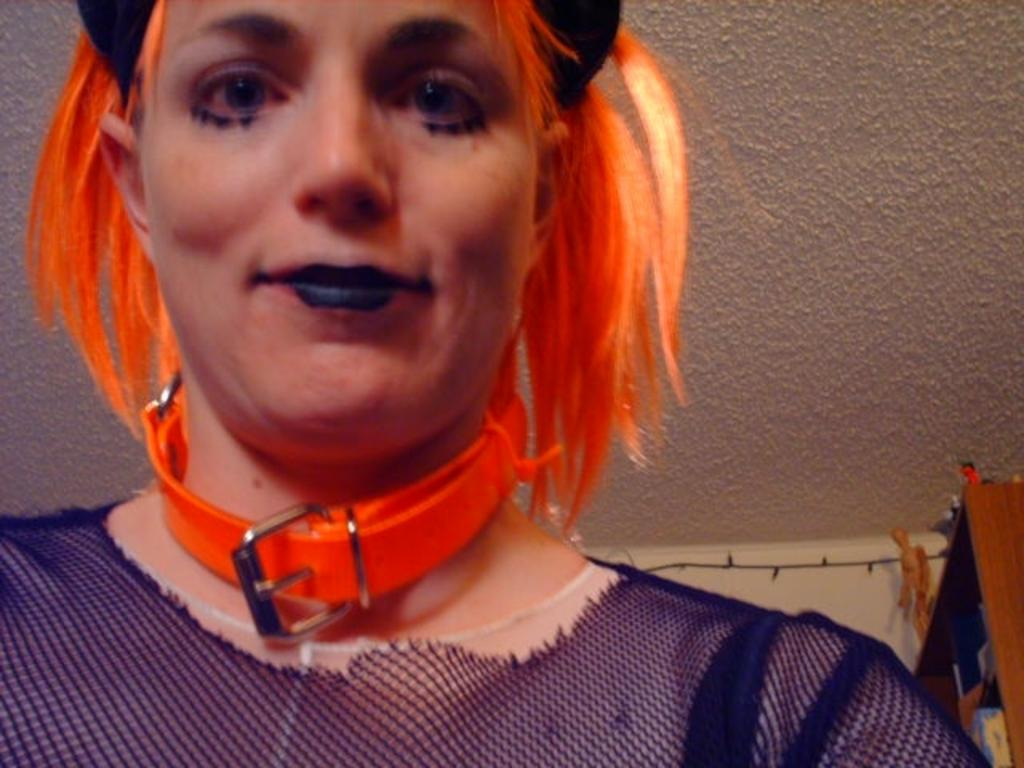What can be seen in the image, specifically in the foreground? There is a person in the image, but only a part of the person is visible. What can be seen in the background of the image? There are objects in the background of the image, and there is also a wall. Can you describe the wall in the background? The wall is a part of the background and provides context for the image. How does the person in the image demonstrate respect and harmony with the objects in the background? The image does not show any interaction between the person and the objects in the background, nor does it provide any information about respect or harmony. 